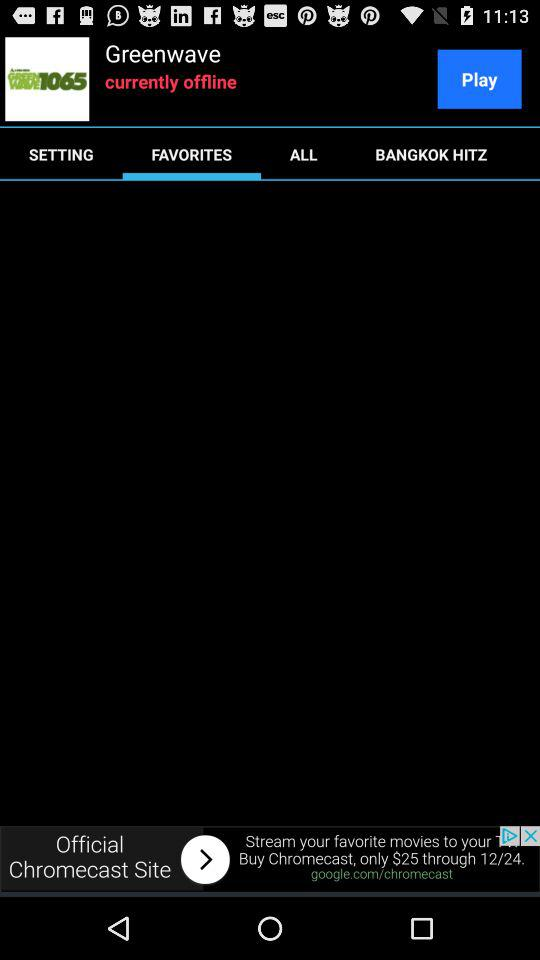What is the application name? The application name is "Greenwave". 